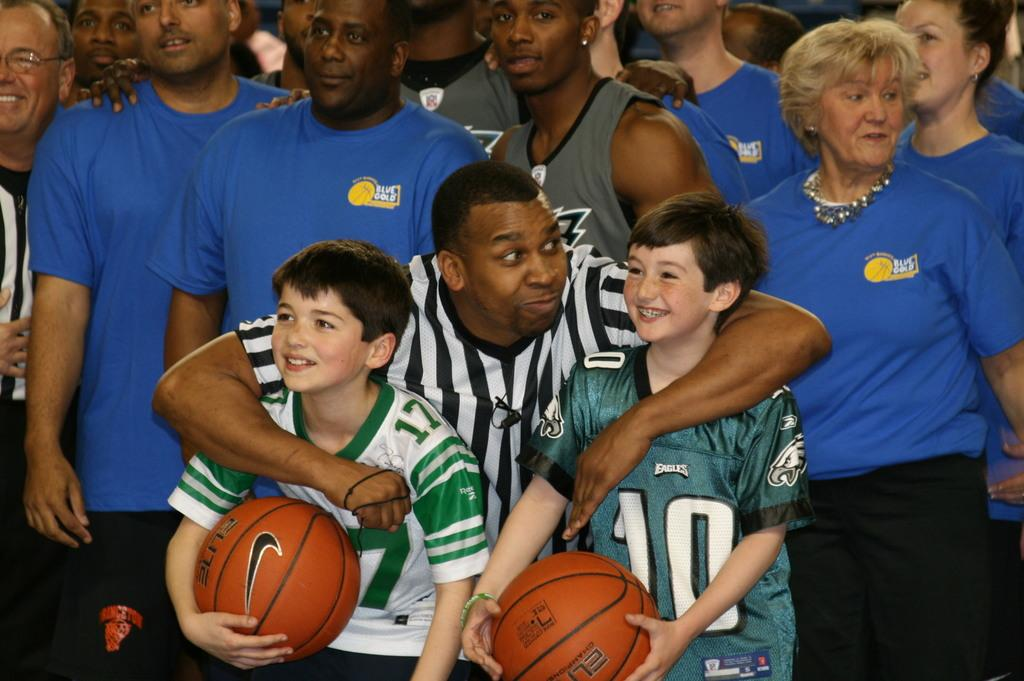How many children are in the foreground of the image? There are two children in the foreground of the image. What are the children holding in their hands? The children are holding balls. Can you describe what is happening in the background of the image? There are people visible in the background of the image. What type of dinosaurs can be seen in the image? There are no dinosaurs present in the image. What knowledge can be gained from the image? The image does not convey any specific knowledge or information beyond the presence of two children holding balls and people visible in the background. 